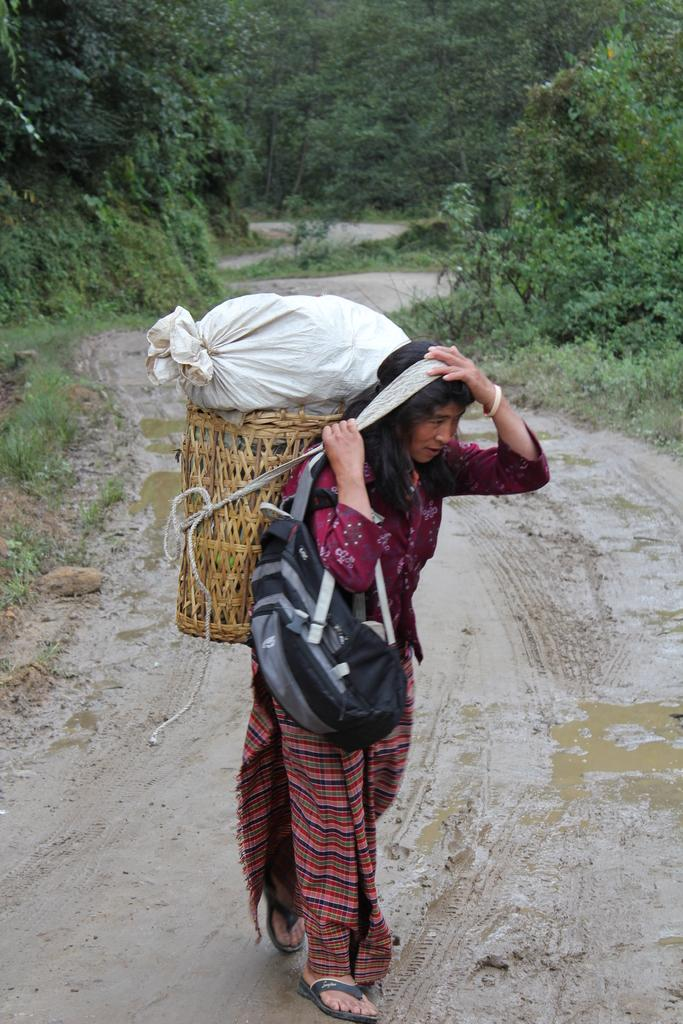Who is the main subject in the image? There is a woman in the image. What is the woman doing in the image? The woman is walking on a pathway. What is the woman carrying in the image? The woman is carrying a basket containing objects. What can be seen in the background of the image? There are plants and a group of trees in the image. What historical event is the woman commemorating in the image? There is no indication of a historical event in the image; it simply shows a woman walking on a pathway. Can you describe the wave pattern on the woman's dress in the image? The woman's dress does not have a wave pattern; it is not mentioned in the provided facts. 